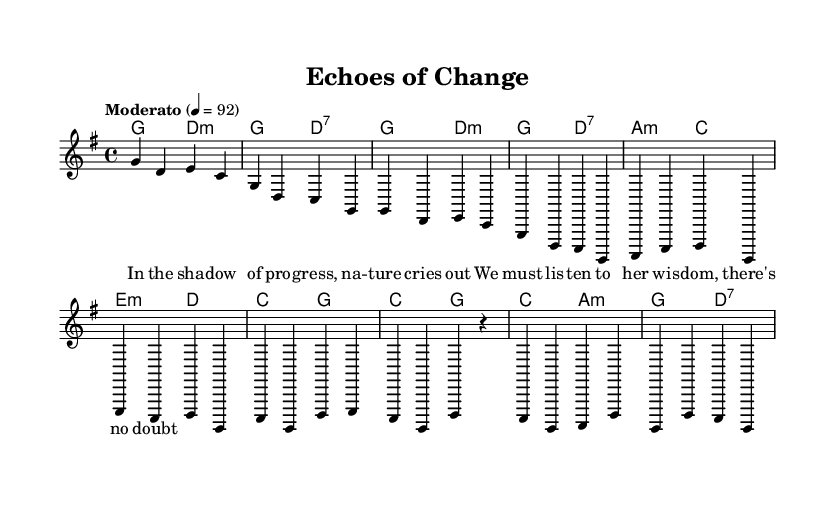What is the key signature of this music? The key signature is G major, which has one sharp (F#). This is derived from the notation in the global section where it is indicated as \key g \major.
Answer: G major What is the time signature of this music? The time signature is 4/4, which indicates four beats per measure. This is noted in the global section where it states \time 4/4.
Answer: 4/4 What is the tempo marking for this piece? The tempo marking is "Moderato," which suggests a moderate speed of 92 beats per minute. This information is conveyed in the global section where it is indicated as \tempo "Moderato" 4 = 92.
Answer: Moderato How many measures are in the introduction? There are 2 measures in the introduction, as indicated by the notes that are grouped in the initial part of the melody section.
Answer: 2 What type of chord is used in the second chord of the intro? The second chord in the introduction is a D7 chord, which is indicated in the harmonies section as d2:7. Chords marked with a colon followed by additional symbols represent their qualities.
Answer: D7 Which lyrical theme is expressed in the verse? The verse expresses themes of progress and nature's wisdom, as shown in the lyrics that depict listening to nature and recognizing its importance. This thematic interpretation can be derived from the words provided in the verse of the lyricmode.
Answer: Social justice and environmental awareness How is the chorus structured musically? The chorus is structured with a four-measure pattern, featuring the chords C, G, D, and A in an alternating manner. This is analyzed by looking at the chord progression in the harmonies section under the chorus lines.
Answer: Four measures 